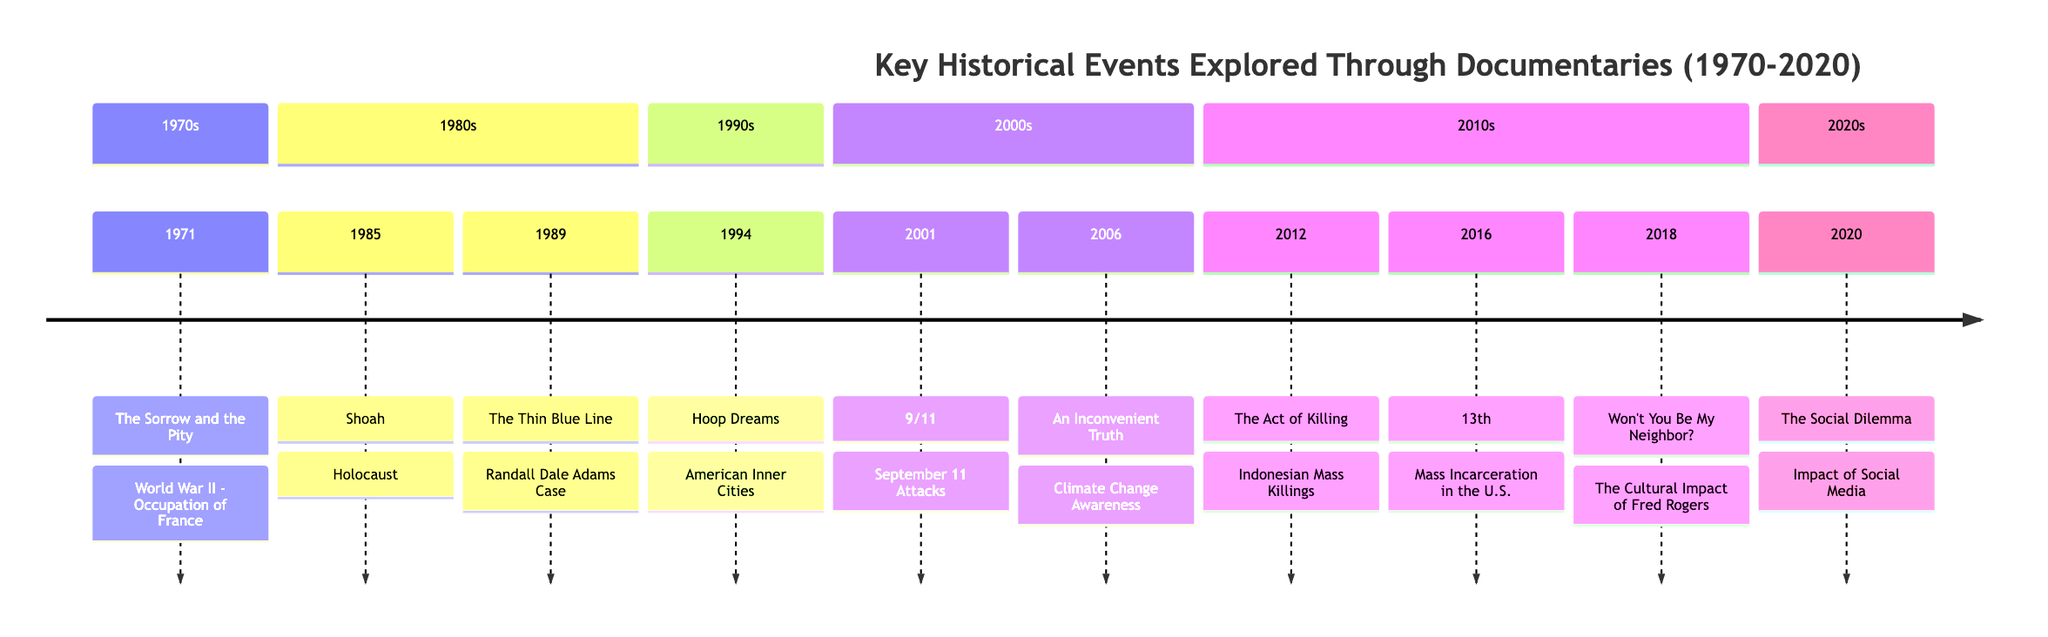What event is associated with the documentary "The Sorrow and the Pity"? The diagram shows that "The Sorrow and the Pity," released in 1971, is linked to the event "World War II - Occupation of France."
Answer: World War II - Occupation of France How many documentaries are listed in the timeline for the 2010s? Counting the entries from the section titled "2010s," there are three documentaries: "The Act of Killing," "13th," and "Won't You Be My Neighbor?"
Answer: 3 Which documentary from the 2000s addresses climate change? In the 2000s section of the timeline, "An Inconvenient Truth," which deals with climate change awareness, is specified.
Answer: An Inconvenient Truth What year was "Hoop Dreams" released? In the timeline, "Hoop Dreams" is clearly marked under the 1994 entry, indicating that it was released that year.
Answer: 1994 What is the critical analysis of "The Thin Blue Line"? The critical analysis section shows that "The Thin Blue Line" is described as revolutionary for its use of cinematic reenactments to deconstruct the American criminal justice system.
Answer: Revolutionary in its use of cinematic reenactments What is the event corresponding to the documentary "13th"? The timeline indicates that "13th," released in 2016, is connected to the event "Mass Incarceration in the U.S."
Answer: Mass Incarceration in the U.S Which section contains the documentary "Shoah"? By analyzing the timeline, "Shoah" is found in the 1980s section, as indicated in the layout of the diagram.
Answer: 1980s What critical theme does "The Act of Killing" explore? The synopsis specifies that "The Act of Killing" examines the Indonesian mass killings, particularly through its innovative approach using reenactments by perpetrators.
Answer: Indonesian Mass Killings What significant event does the documentary "9/11" depict? The timeline connects "9/11," released in 2001, to the significant event of the "September 11 Attacks," showing its relevance.
Answer: September 11 Attacks 